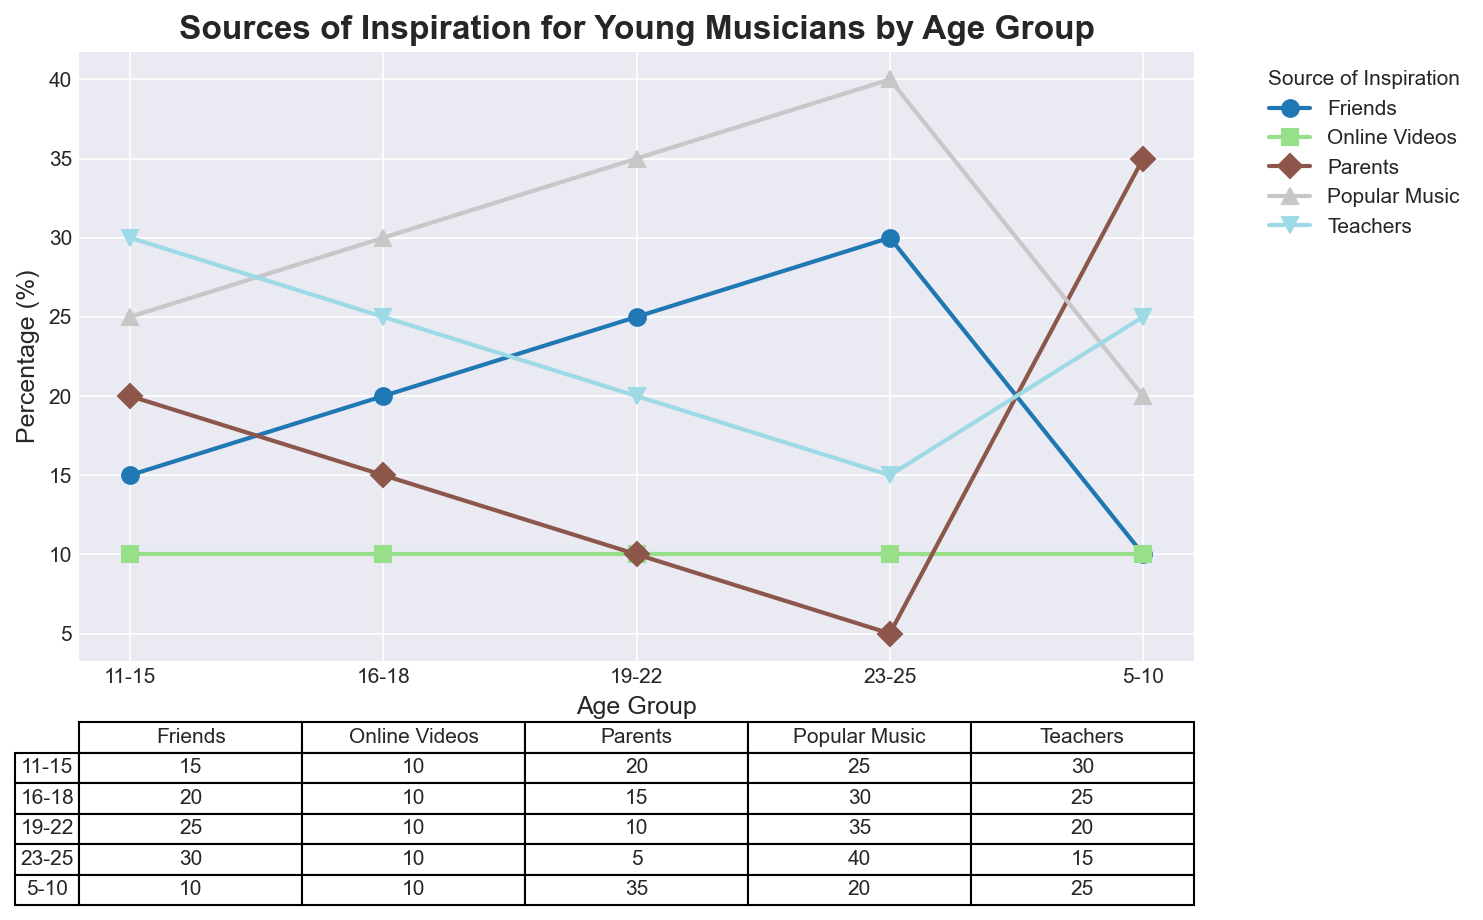Which age group has the highest percentage of inspiration from parents? Look at the line representing parents and find the age group with the highest value in the table below the figure. For parents, the highest percentage is 35% for the 5-10 age group.
Answer: 5-10 How does the percentage of inspiration from teachers change with age? Follow the line representing teachers through the age groups and check the table values: 5-10 (25%), 11-15 (30%), 16-18 (25%), 19-22 (20%), 23-25 (15%). The percentage increases to 30% at 11-15 and then gradually decreases to 15% at 23-25.
Answer: Increases and then decreases Which two age groups have the largest difference in the percentage of inspiration from friends? Look at the percentage of friends in each age group and find the two values with the maximum difference: 23-25 (30%) and 5-10 (10%) have the largest difference of 20 percentage points.
Answer: 23-25 and 5-10 Compare the popularity of online videos as a source of inspiration across all age groups. Examine the percentages for online videos in each age group. All age groups have an equal percentage of 10%.
Answer: Equal across all age groups What is the combined percentage of inspiration from popular music and friends for the 19-22 age group? Add the percentages for popular music (35%) and friends (25%) for the 19-22 age group: 35% + 25% = 60%.
Answer: 60% What trend do you notice for the percentage of inspiration from parents as musicians get older? Observe the parent line and check the table values: 5-10 (35%), 11-15 (20%), 16-18 (15%), 19-22 (10%), 23-25 (5%). The trend shows a consistent decrease.
Answer: Decreases with age Which source of inspiration has the highest overall percentage in any given age group? Identify the highest value in the table: Popular music at 40% for the 23-25 age group.
Answer: Popular music in 23-25 How does the percentage of inspiration from popular music compare between the 5-10 and 16-18 age groups? Review the percentages for popular music in 5-10 (20%) and 16-18 (30%). The 16-18 age group has a higher percentage by 10 points.
Answer: 16-18 is higher by 10 points 